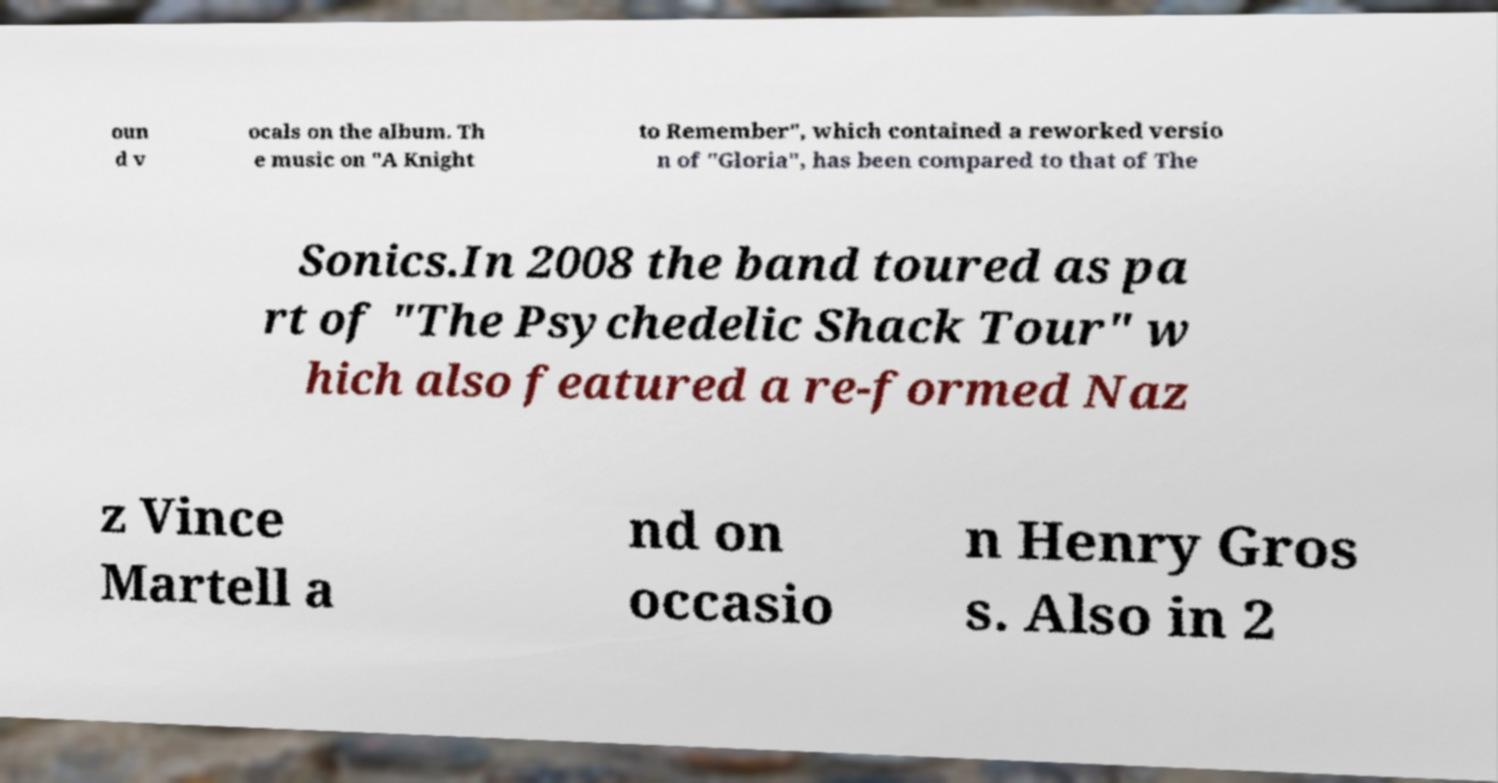Can you read and provide the text displayed in the image?This photo seems to have some interesting text. Can you extract and type it out for me? oun d v ocals on the album. Th e music on "A Knight to Remember", which contained a reworked versio n of "Gloria", has been compared to that of The Sonics.In 2008 the band toured as pa rt of "The Psychedelic Shack Tour" w hich also featured a re-formed Naz z Vince Martell a nd on occasio n Henry Gros s. Also in 2 